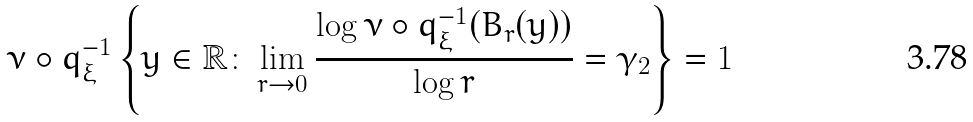Convert formula to latex. <formula><loc_0><loc_0><loc_500><loc_500>\nu \circ q _ { \xi } ^ { - 1 } \left \{ y \in \mathbb { R } \colon \lim _ { r \rightarrow 0 } \frac { \log \nu \circ q _ { \xi } ^ { - 1 } ( B _ { r } ( y ) ) } { \log r } = \gamma _ { 2 } \right \} = 1</formula> 